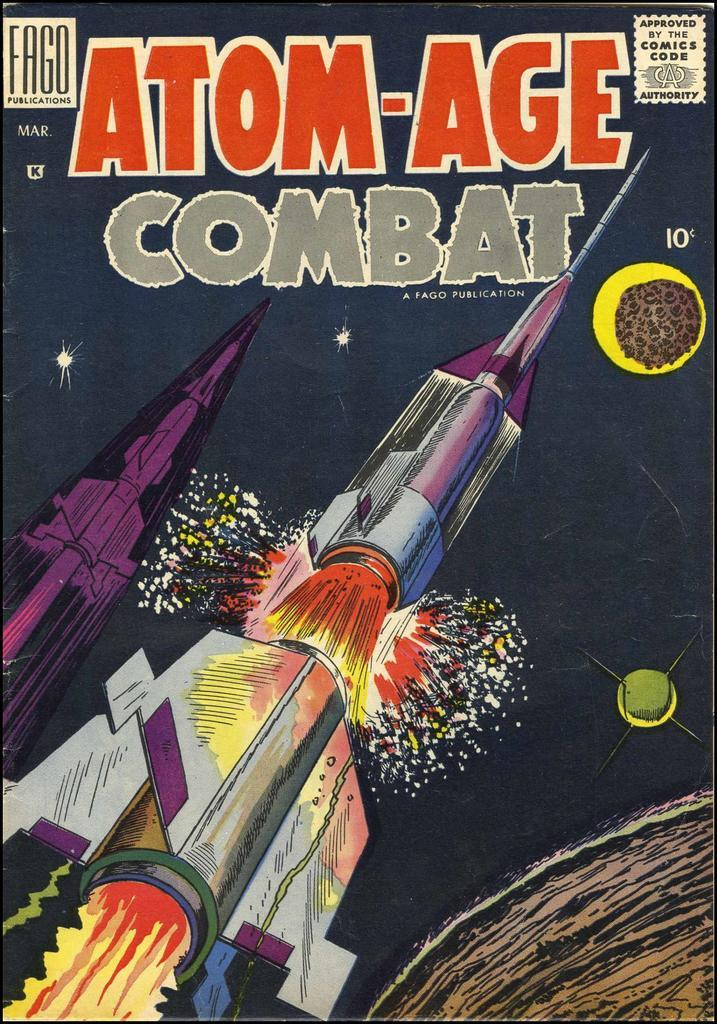Provide a one-sentence caption for the provided image. A ten cent comic called Atom-Age Combat is produced by Fago Publications. 